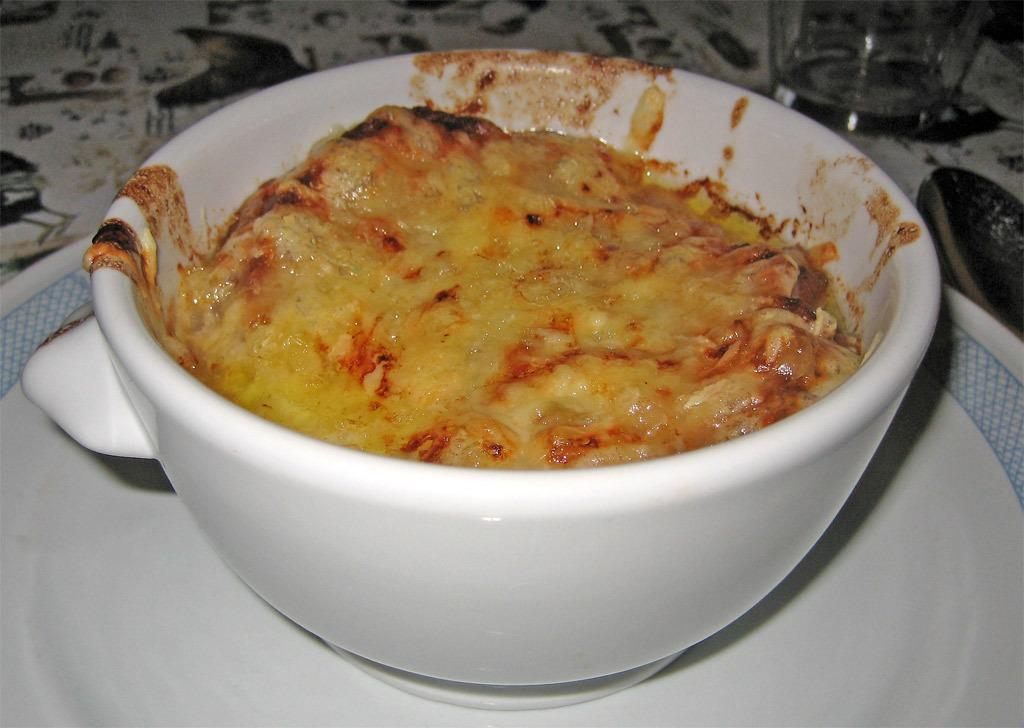What is in the bowl that is visible in the image? There is food in a bowl in the image. What other objects can be seen on the plate in the image? There is a ball placed on a plate in the image. What might be used for drinking in the image? There is a drinking glass in the image. What utensil is located at the right side of the image? There is a spoon at the right side of the image. What type of government is depicted in the image? There is no depiction of a government in the image; it features food, a ball, a drinking glass, and a spoon. 